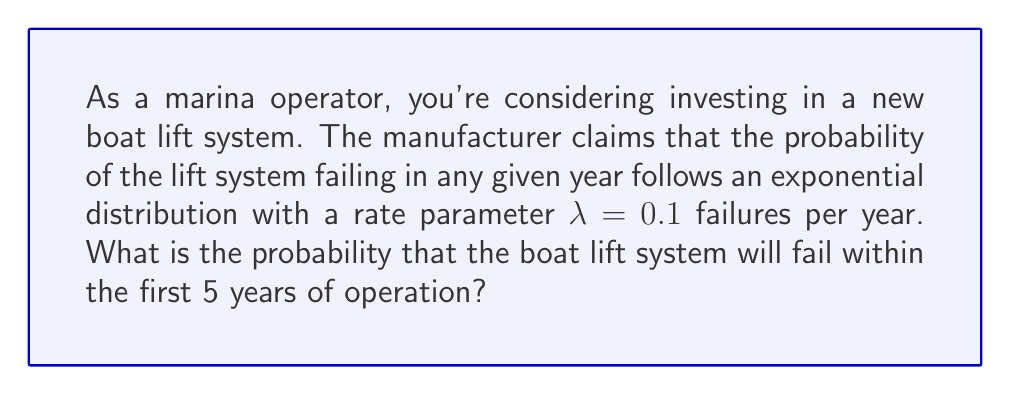Can you answer this question? To solve this problem, we need to use the cumulative distribution function (CDF) of the exponential distribution. The CDF for an exponential distribution is given by:

$$F(t) = 1 - e^{-\lambda t}$$

Where:
$F(t)$ is the probability of failure within time $t$
$\lambda$ is the rate parameter
$t$ is the time period

Given:
$\lambda = 0.1$ failures per year
$t = 5$ years

Let's substitute these values into the CDF equation:

$$F(5) = 1 - e^{-0.1 \cdot 5}$$

$$F(5) = 1 - e^{-0.5}$$

Now, let's calculate this:

$$F(5) = 1 - 0.6065$$

$$F(5) = 0.3935$$

Therefore, the probability that the boat lift system will fail within the first 5 years of operation is approximately 0.3935 or 39.35%.
Answer: The probability that the boat lift system will fail within the first 5 years of operation is approximately 0.3935 or 39.35%. 